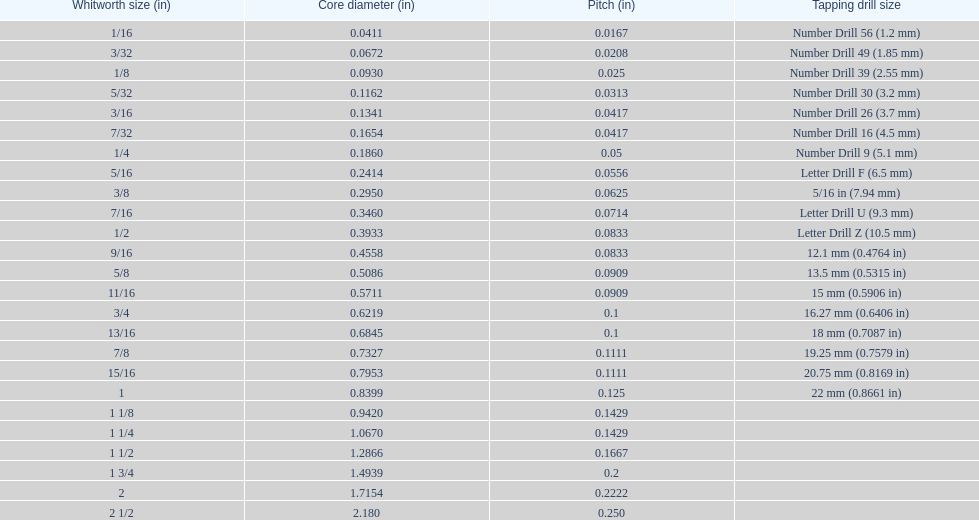What is the least core diameter (in)? 0.0411. 